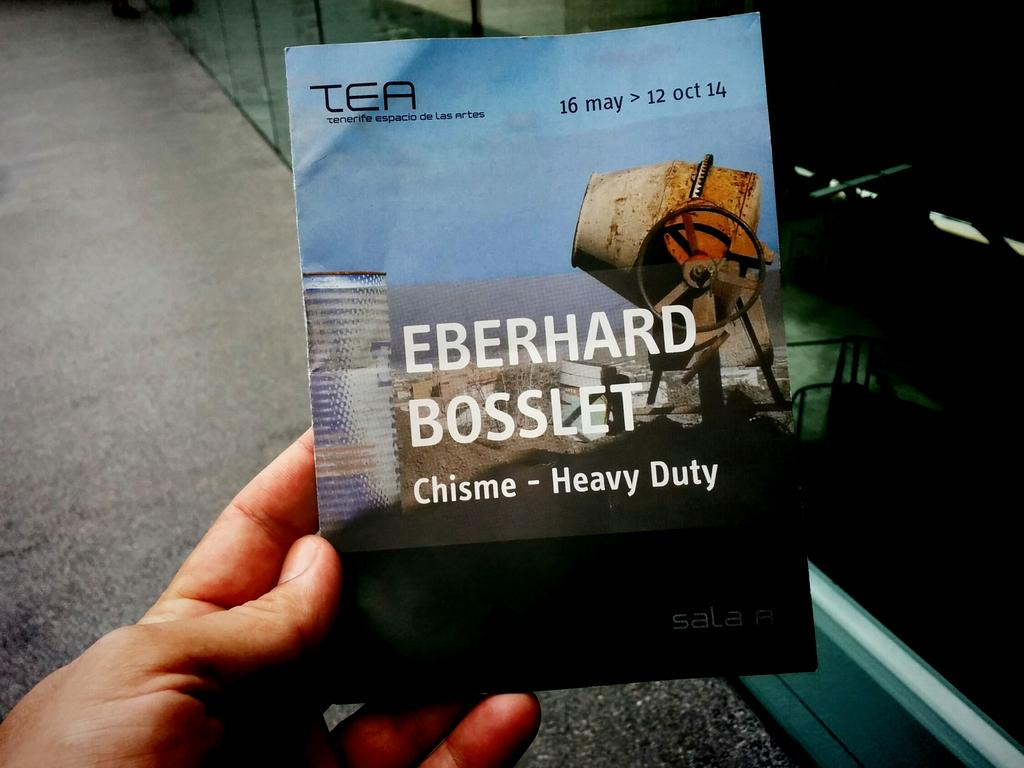Provide a one-sentence caption for the provided image. a book called chisme heavy duty and a man is holding it. 